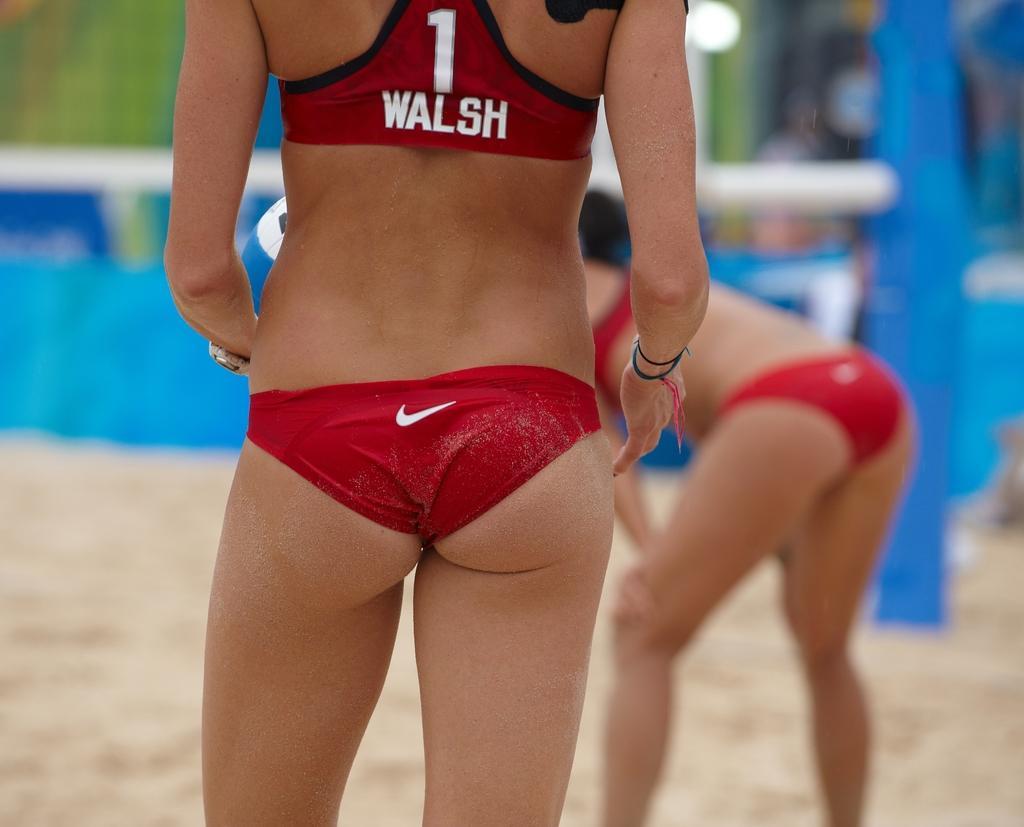In one or two sentences, can you explain what this image depicts? In this image we can see a lady standing. At the bottom there is sand. In the background there is a board. 